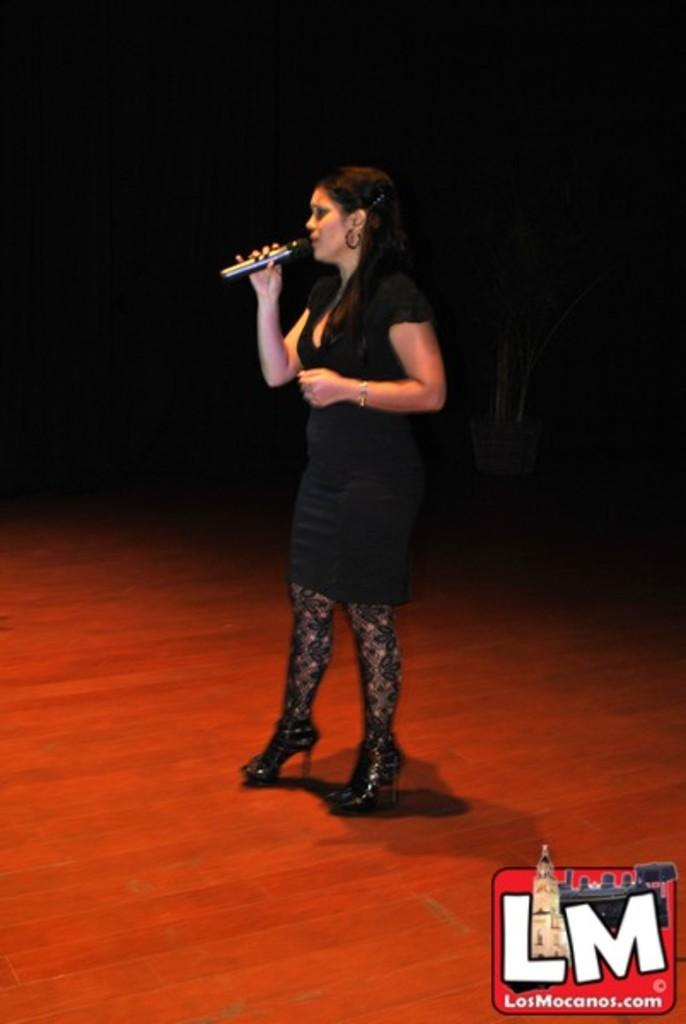Who is the main subject in the image? There is a woman in the image. What is the woman doing in the image? The woman is standing on the floor and holding a mic in her hand. Can you describe the background of the image? The background of the image is completely dark. Is there any additional information or markings in the image? Yes, there is a watermark in the bottom right side of the image. Is there a wristwatch visible on the woman's wrist in the image? There is no wristwatch visible on the woman's wrist in the image. 